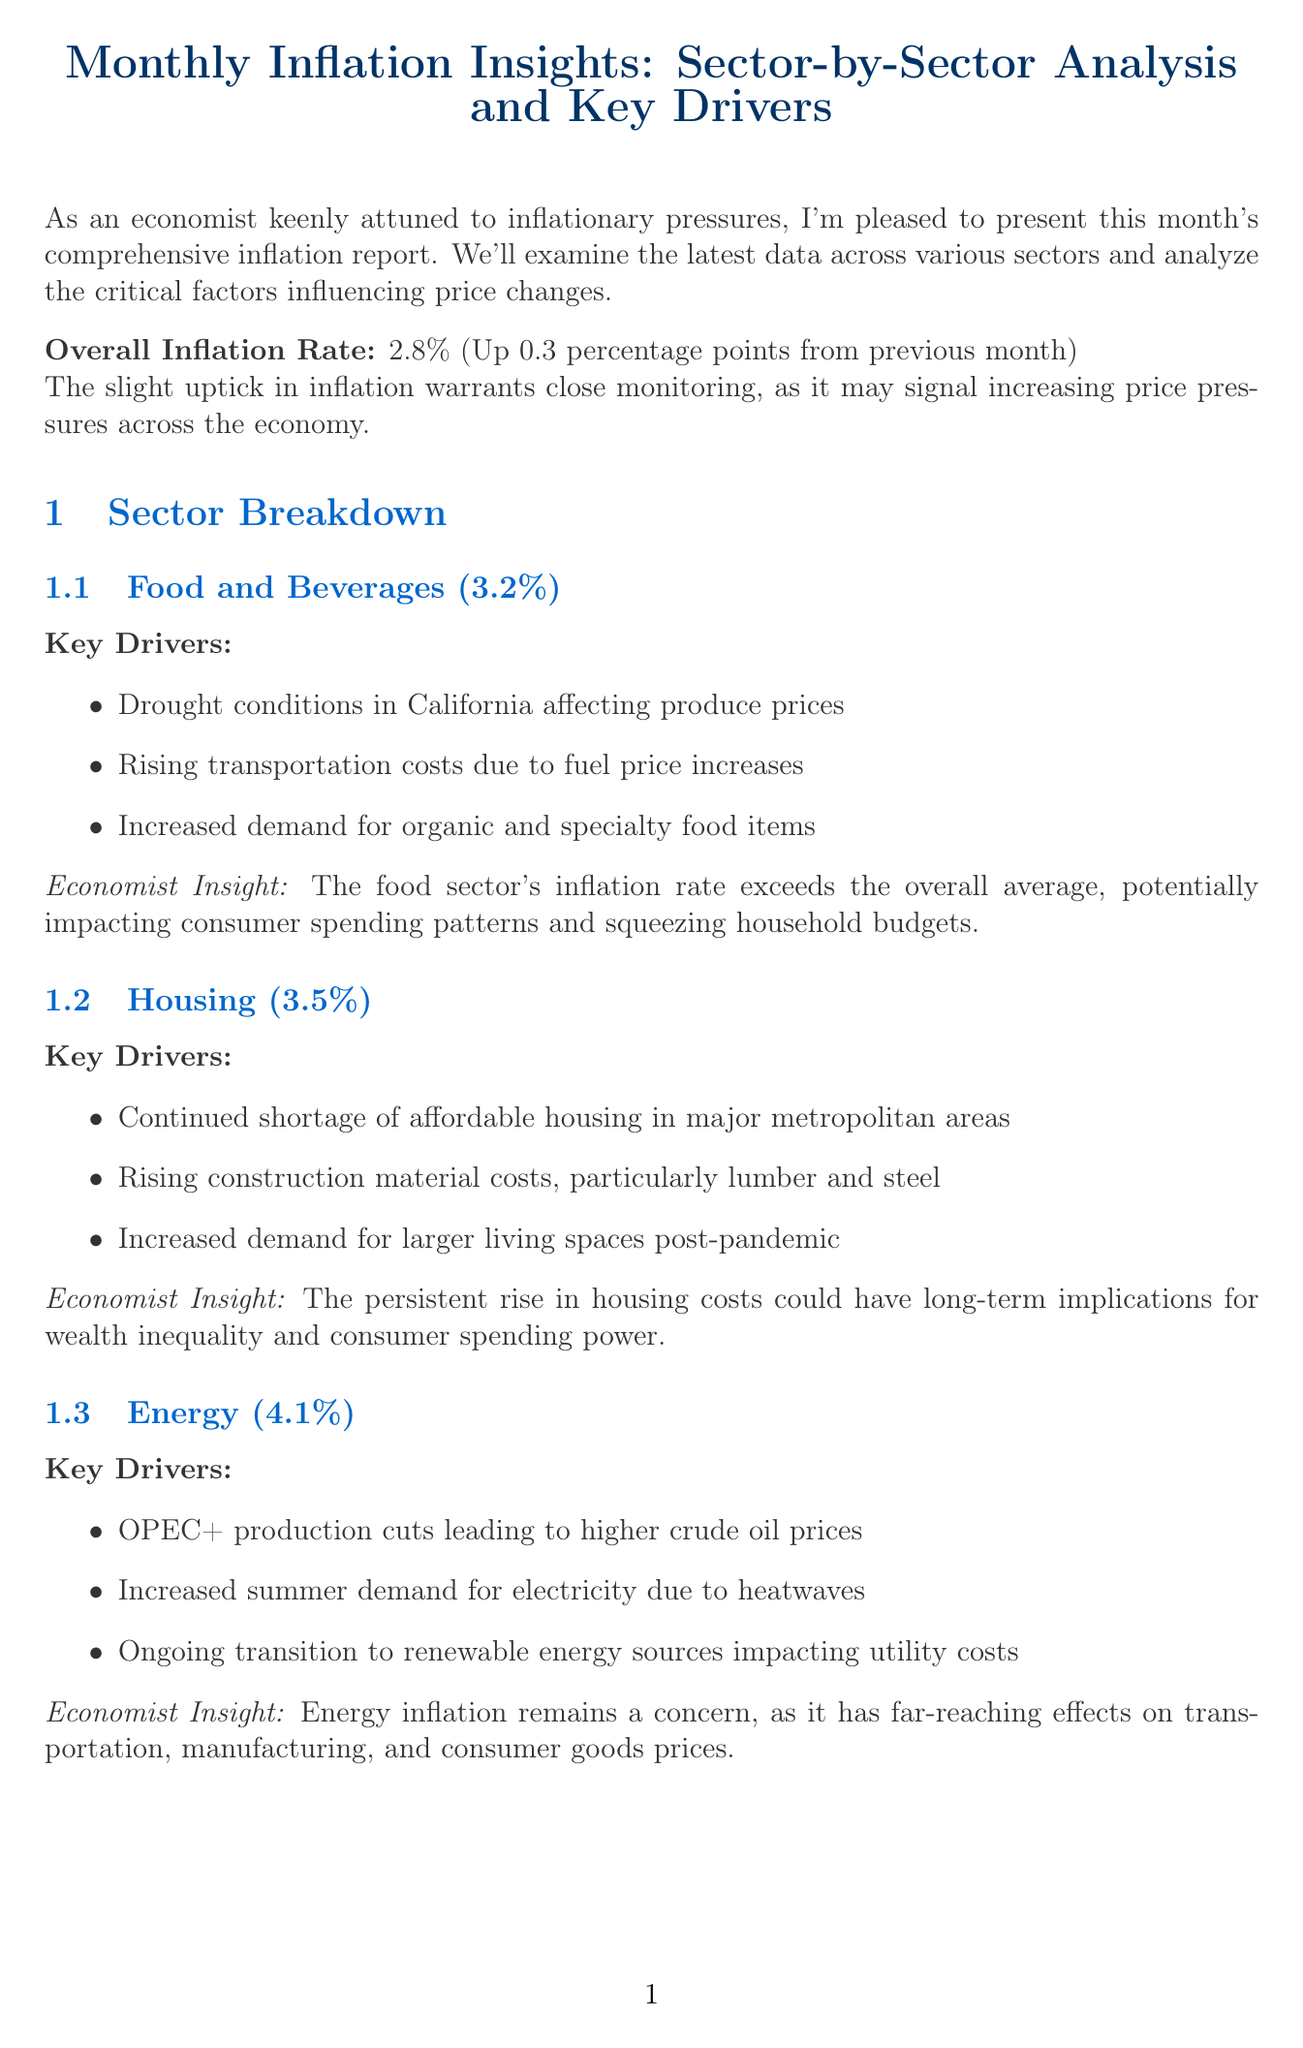What is the overall inflation rate? The overall inflation rate is explicitly stated in the document as 2.8%.
Answer: 2.8% What was the inflation rate for Housing? The document provides specific inflation rates for each sector, including Housing at 3.5%.
Answer: 3.5% What are the key drivers for Energy inflation? The document lists three key drivers affecting Energy inflation, namely OPEC+ production cuts, increased summer demand for electricity, and ongoing transition to renewable energy sources.
Answer: OPEC+ production cuts, increased summer demand for electricity, ongoing transition to renewable energy sources What impact does the rising housing cost have according to the document? The insight provided for Housing discusses implications for wealth inequality and consumer spending power due to rising costs.
Answer: Wealth inequality and consumer spending power What is the projected change in the Federal Funds Rate? The document mentions the Federal Reserve's likely maintenance of its hawkish stance, suggesting a potential for one more rate hike this year.
Answer: One more rate hike What is the value of the Consumer Price Index (CPI)? The document quotes the value of the CPI at 284.5.
Answer: 284.5 What does the conclusion emphasize about monitoring economic indicators? The conclusion highlights the importance of monitoring both domestic and global economic indicators to anticipate future trends.
Answer: Anticipate future trends What is the inflation rate for Healthcare? The document specifies the inflation rate for Healthcare as 2.4%.
Answer: 2.4% 